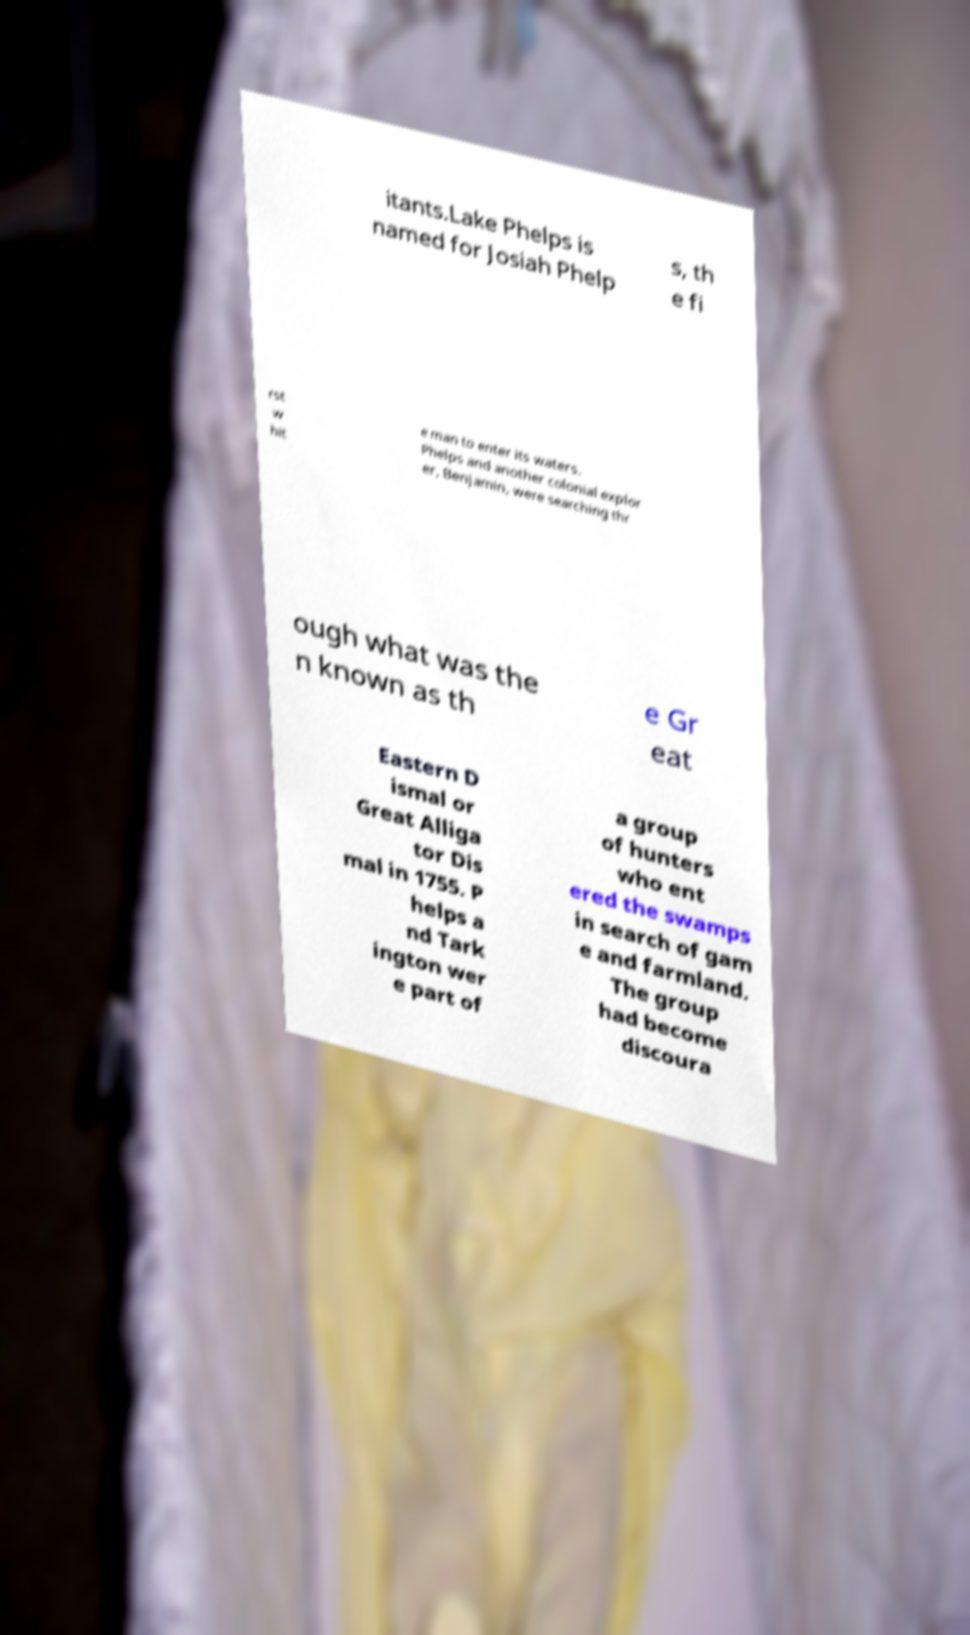Please identify and transcribe the text found in this image. itants.Lake Phelps is named for Josiah Phelp s, th e fi rst w hit e man to enter its waters. Phelps and another colonial explor er, Benjamin, were searching thr ough what was the n known as th e Gr eat Eastern D ismal or Great Alliga tor Dis mal in 1755. P helps a nd Tark ington wer e part of a group of hunters who ent ered the swamps in search of gam e and farmland. The group had become discoura 